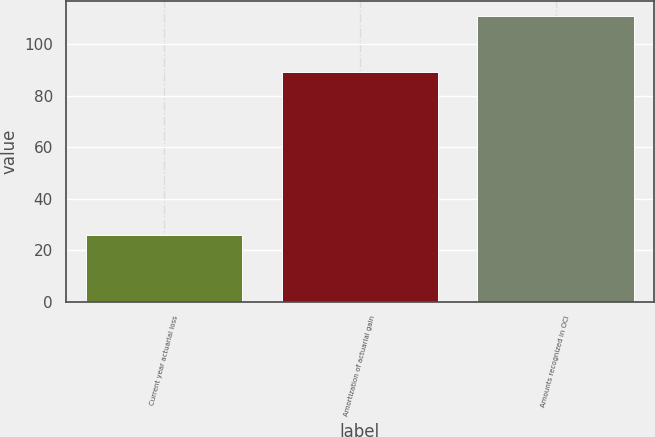Convert chart. <chart><loc_0><loc_0><loc_500><loc_500><bar_chart><fcel>Current year actuarial loss<fcel>Amortization of actuarial gain<fcel>Amounts recognized in OCI<nl><fcel>26<fcel>89<fcel>111<nl></chart> 